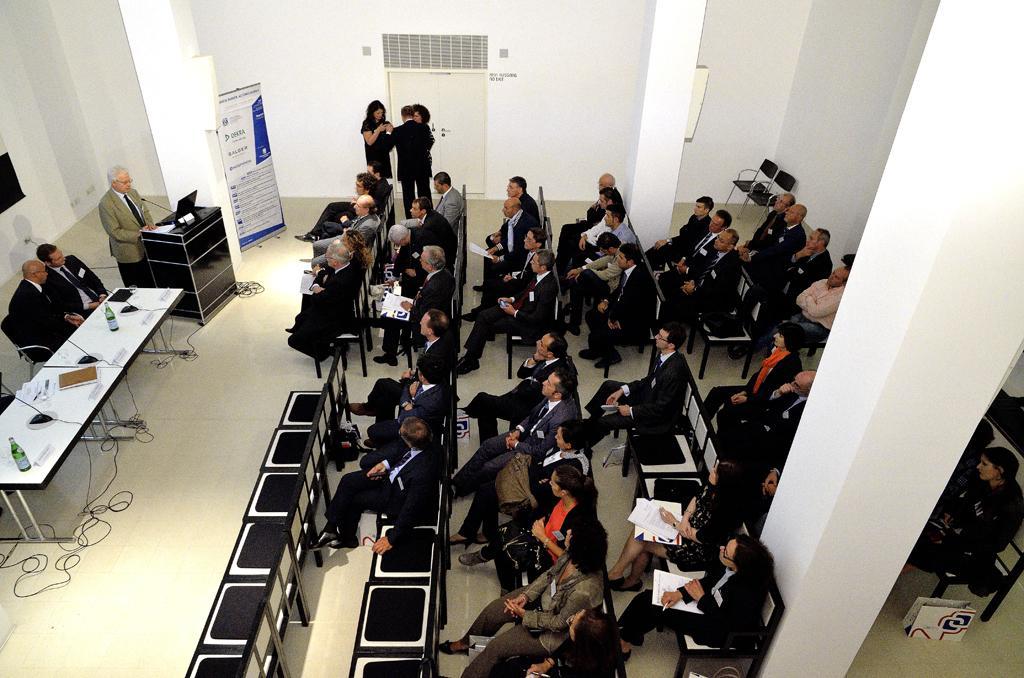Can you describe this image briefly? In this picture I can see group of people sitting on the chairs. l can see few people standing. There is a man standing near the podium. I can see a mile and a laptop on the podium. There are miles, cables, bottles, nameplates and some other objects on the tables. I can see pillars, banner and some other objects. 